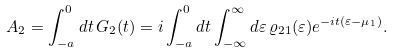Convert formula to latex. <formula><loc_0><loc_0><loc_500><loc_500>A _ { 2 } = \int _ { - a } ^ { 0 } d t \, G _ { 2 } ( t ) = i \int _ { - a } ^ { 0 } d t \int _ { - \infty } ^ { \infty } d \varepsilon \, \varrho _ { 2 1 } ( \varepsilon ) e ^ { - i t ( \varepsilon - \mu _ { 1 } ) } .</formula> 